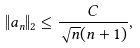Convert formula to latex. <formula><loc_0><loc_0><loc_500><loc_500>\| a _ { n } \| _ { 2 } \leq \frac { C } { \sqrt { n } ( n + 1 ) } ,</formula> 